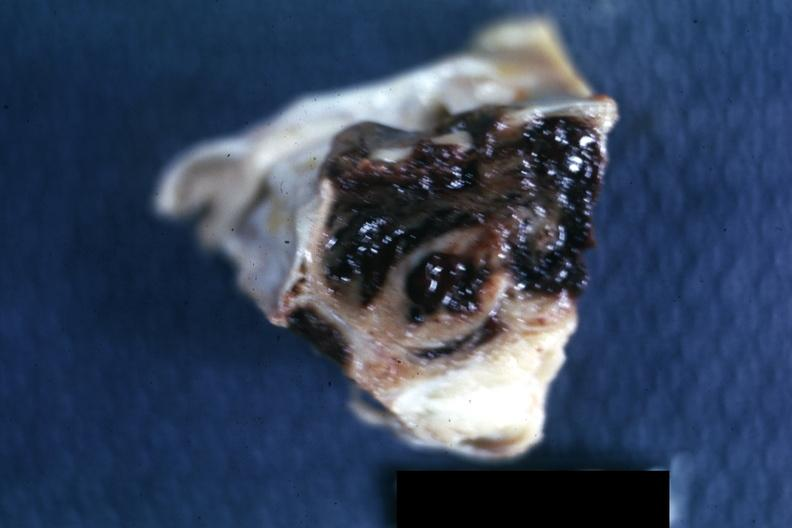what is present?
Answer the question using a single word or phrase. Chromophobe adenoma 